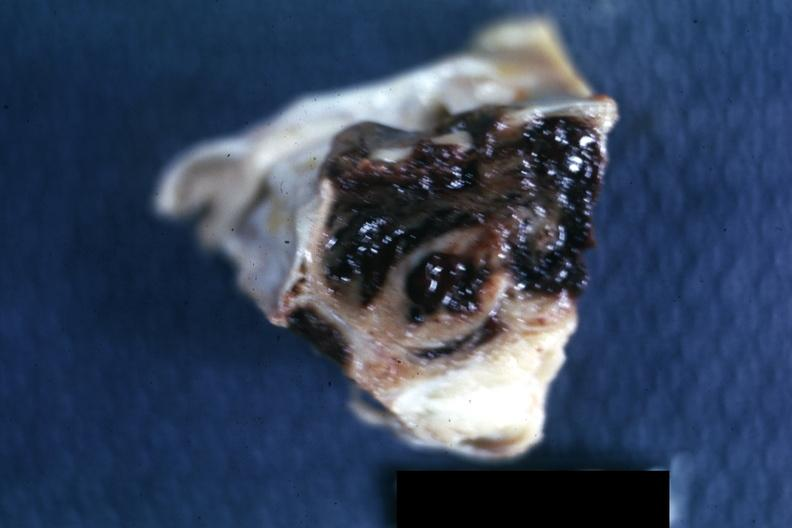what is present?
Answer the question using a single word or phrase. Chromophobe adenoma 